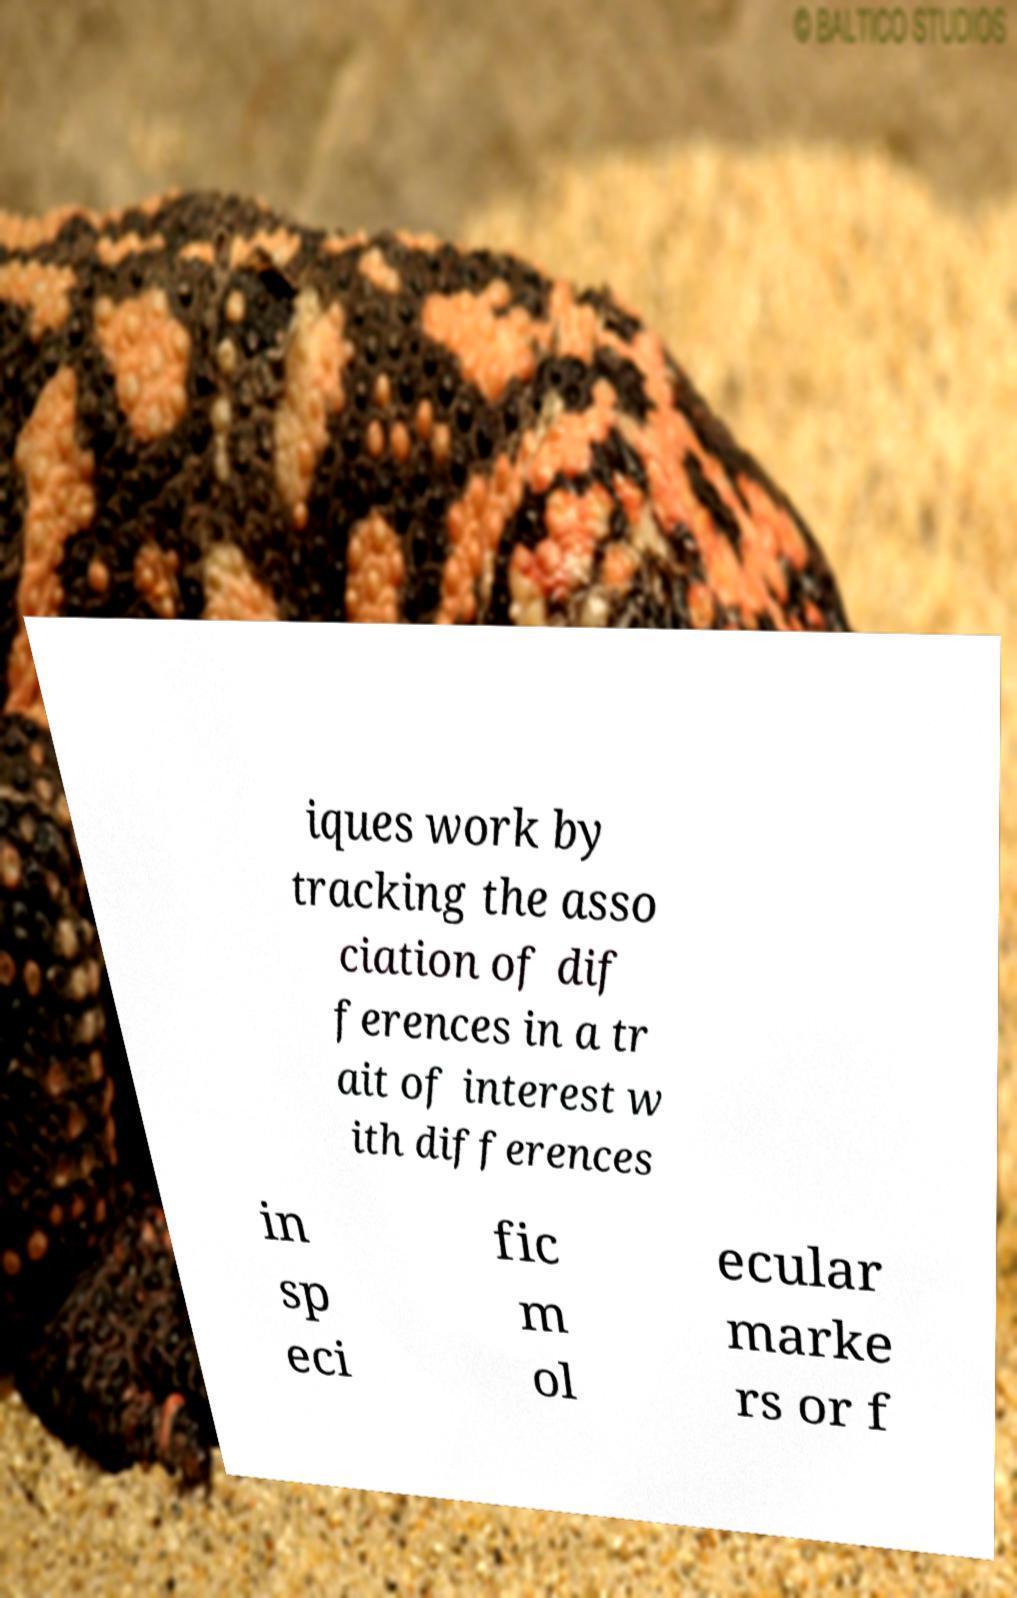What messages or text are displayed in this image? I need them in a readable, typed format. iques work by tracking the asso ciation of dif ferences in a tr ait of interest w ith differences in sp eci fic m ol ecular marke rs or f 